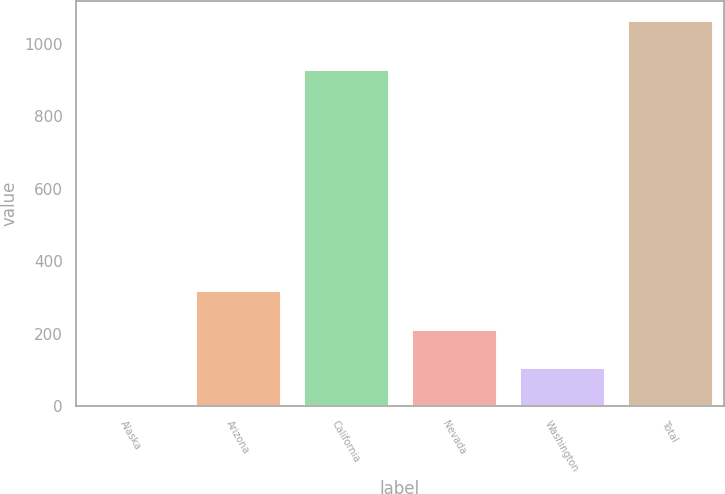Convert chart to OTSL. <chart><loc_0><loc_0><loc_500><loc_500><bar_chart><fcel>Alaska<fcel>Arizona<fcel>California<fcel>Nevada<fcel>Washington<fcel>Total<nl><fcel>1<fcel>320.2<fcel>930<fcel>213.8<fcel>107.4<fcel>1065<nl></chart> 